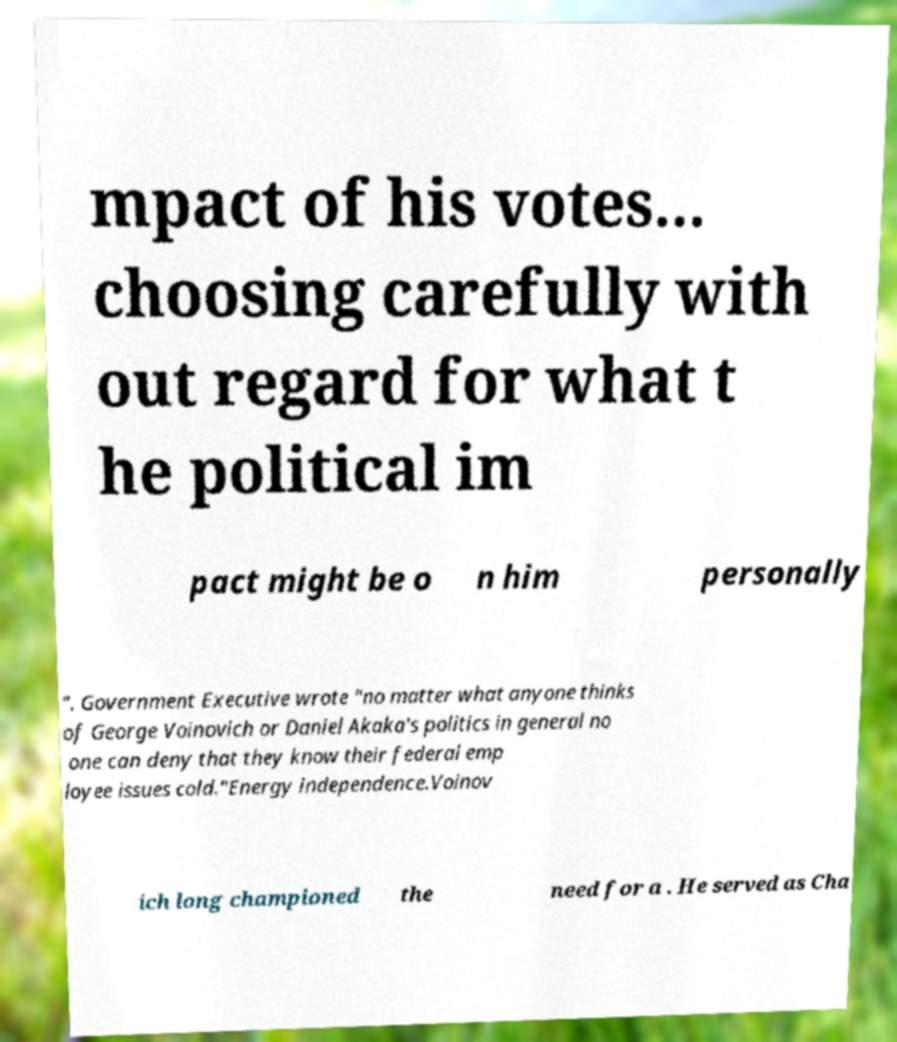There's text embedded in this image that I need extracted. Can you transcribe it verbatim? mpact of his votes... choosing carefully with out regard for what t he political im pact might be o n him personally ". Government Executive wrote "no matter what anyone thinks of George Voinovich or Daniel Akaka's politics in general no one can deny that they know their federal emp loyee issues cold."Energy independence.Voinov ich long championed the need for a . He served as Cha 